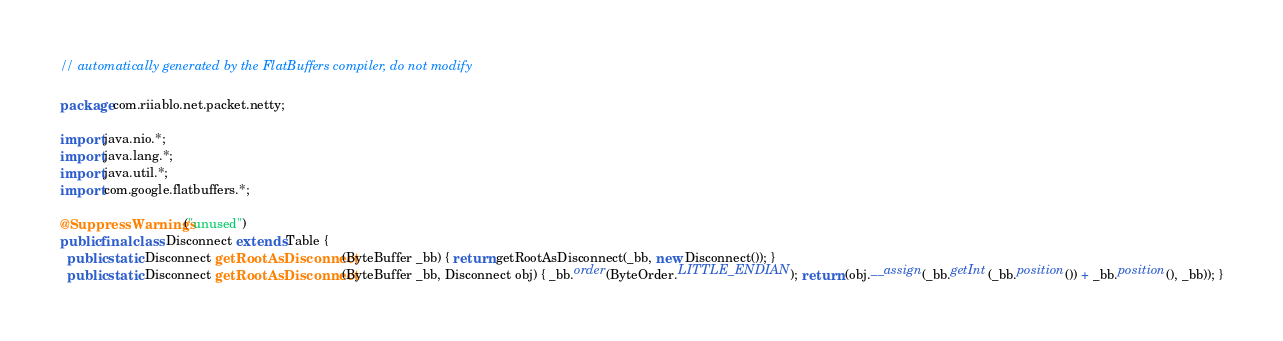Convert code to text. <code><loc_0><loc_0><loc_500><loc_500><_Java_>// automatically generated by the FlatBuffers compiler, do not modify

package com.riiablo.net.packet.netty;

import java.nio.*;
import java.lang.*;
import java.util.*;
import com.google.flatbuffers.*;

@SuppressWarnings("unused")
public final class Disconnect extends Table {
  public static Disconnect getRootAsDisconnect(ByteBuffer _bb) { return getRootAsDisconnect(_bb, new Disconnect()); }
  public static Disconnect getRootAsDisconnect(ByteBuffer _bb, Disconnect obj) { _bb.order(ByteOrder.LITTLE_ENDIAN); return (obj.__assign(_bb.getInt(_bb.position()) + _bb.position(), _bb)); }</code> 